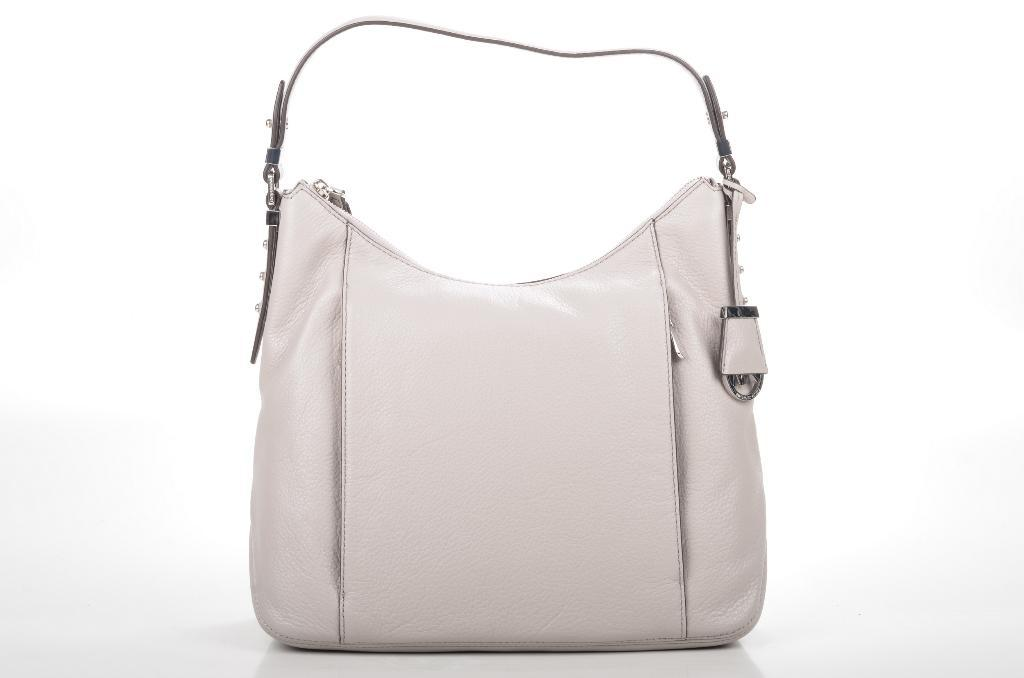What type of handbag is visible in the image? There is a light color woman's handbag in the image. What type of frog can be seen sitting on top of the handbag in the image? There is no frog present in the image; it only features a light color woman's handbag. 